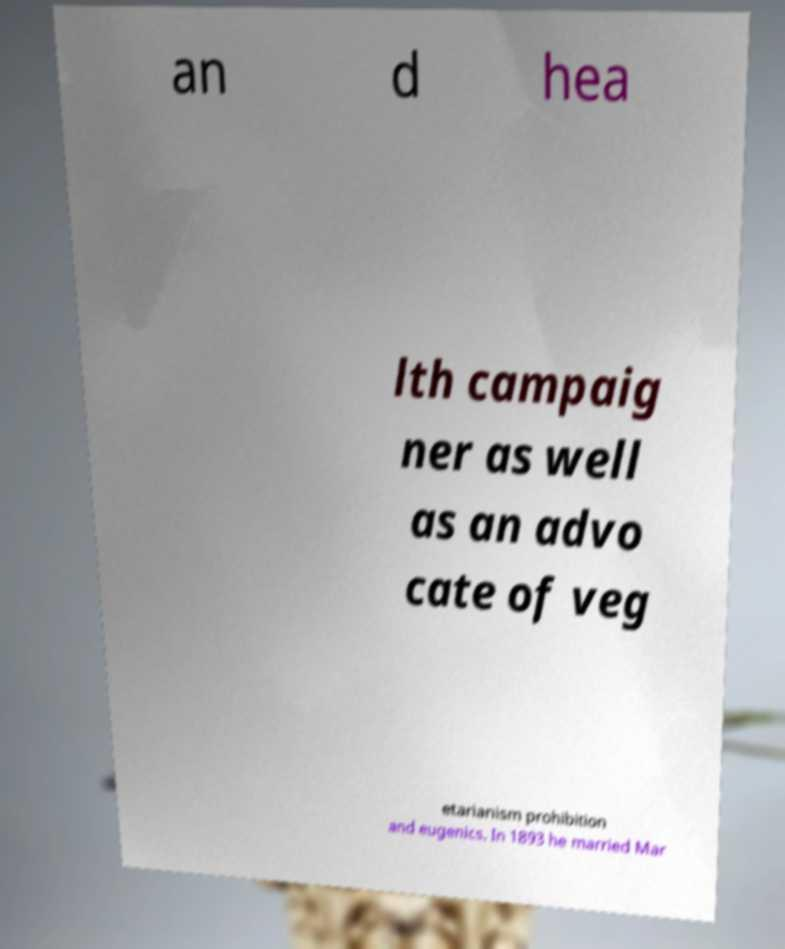Could you assist in decoding the text presented in this image and type it out clearly? an d hea lth campaig ner as well as an advo cate of veg etarianism prohibition and eugenics. In 1893 he married Mar 